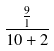<formula> <loc_0><loc_0><loc_500><loc_500>\frac { \frac { 9 } { 1 } } { 1 0 + 2 }</formula> 